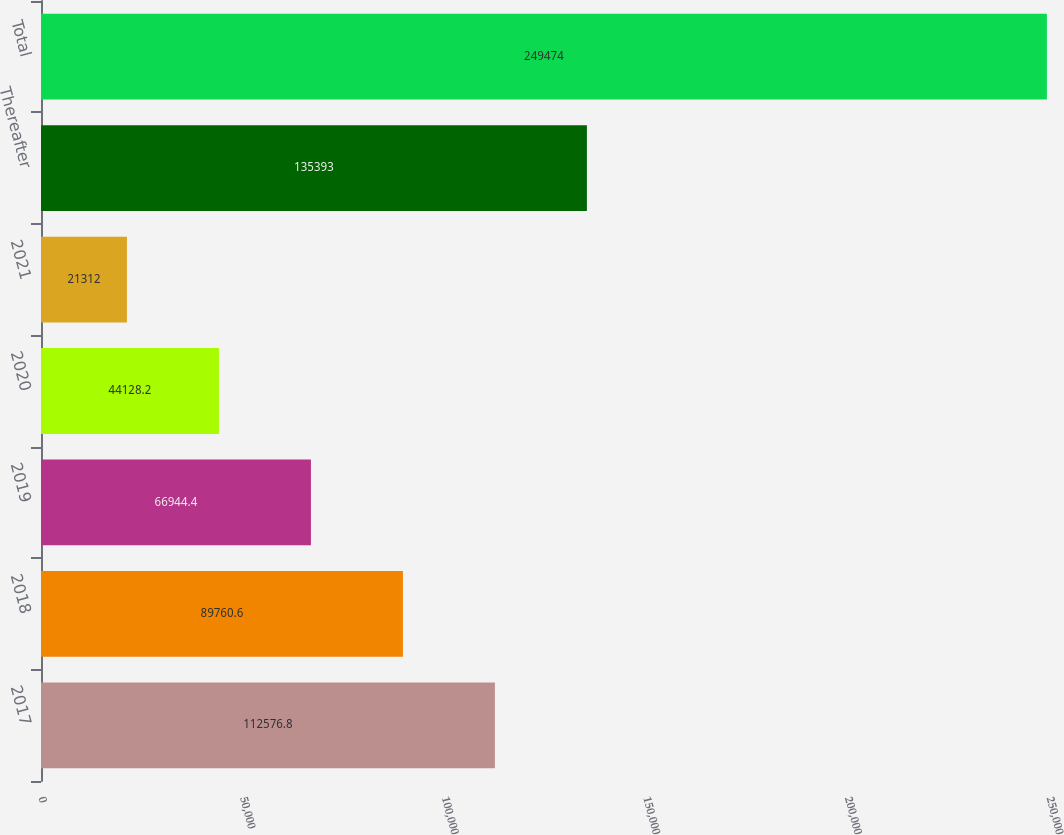Convert chart to OTSL. <chart><loc_0><loc_0><loc_500><loc_500><bar_chart><fcel>2017<fcel>2018<fcel>2019<fcel>2020<fcel>2021<fcel>Thereafter<fcel>Total<nl><fcel>112577<fcel>89760.6<fcel>66944.4<fcel>44128.2<fcel>21312<fcel>135393<fcel>249474<nl></chart> 